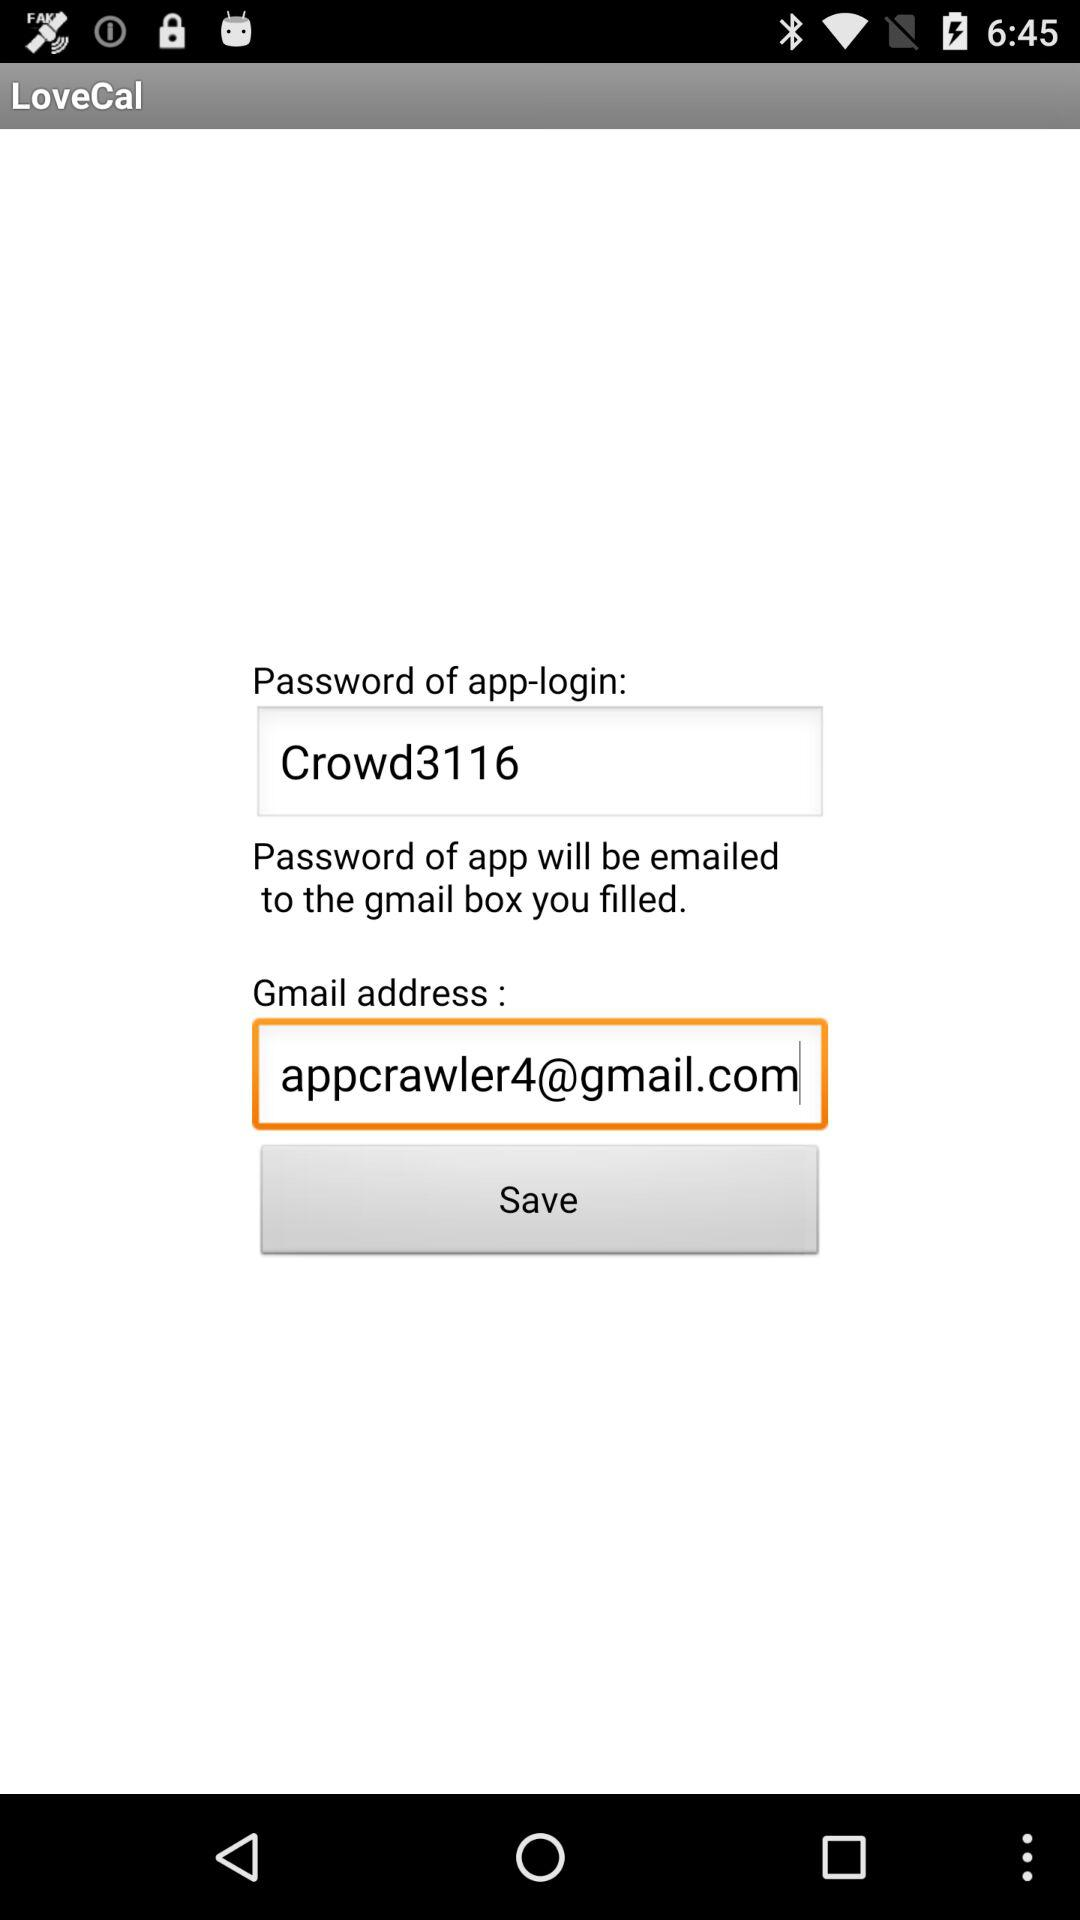When will the password be emailed to the entered Gmail address?
When the provided information is insufficient, respond with <no answer>. <no answer> 